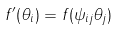Convert formula to latex. <formula><loc_0><loc_0><loc_500><loc_500>f ^ { \prime } ( \theta _ { i } ) = f ( \psi _ { i j } \theta _ { j } )</formula> 